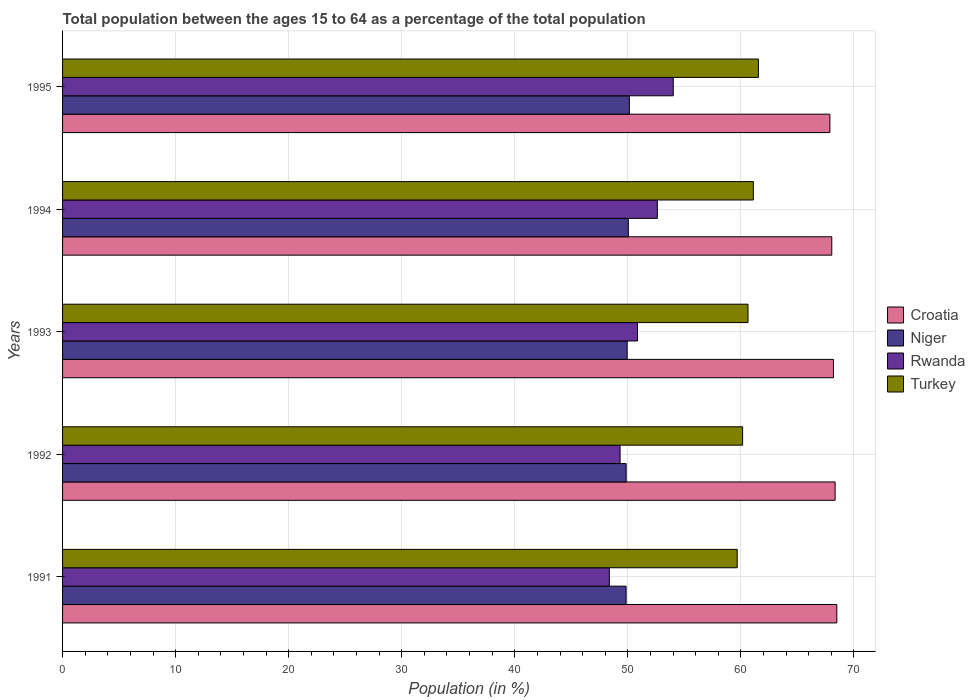How many different coloured bars are there?
Keep it short and to the point. 4. How many groups of bars are there?
Your answer should be very brief. 5. Are the number of bars on each tick of the Y-axis equal?
Provide a short and direct response. Yes. What is the label of the 3rd group of bars from the top?
Provide a succinct answer. 1993. What is the percentage of the population ages 15 to 64 in Croatia in 1994?
Give a very brief answer. 68.04. Across all years, what is the maximum percentage of the population ages 15 to 64 in Croatia?
Provide a succinct answer. 68.48. Across all years, what is the minimum percentage of the population ages 15 to 64 in Turkey?
Make the answer very short. 59.67. What is the total percentage of the population ages 15 to 64 in Turkey in the graph?
Offer a very short reply. 303.11. What is the difference between the percentage of the population ages 15 to 64 in Turkey in 1991 and that in 1993?
Provide a succinct answer. -0.96. What is the difference between the percentage of the population ages 15 to 64 in Niger in 1992 and the percentage of the population ages 15 to 64 in Turkey in 1995?
Ensure brevity in your answer.  -11.7. What is the average percentage of the population ages 15 to 64 in Rwanda per year?
Give a very brief answer. 51.03. In the year 1992, what is the difference between the percentage of the population ages 15 to 64 in Rwanda and percentage of the population ages 15 to 64 in Niger?
Make the answer very short. -0.54. What is the ratio of the percentage of the population ages 15 to 64 in Rwanda in 1992 to that in 1993?
Offer a very short reply. 0.97. Is the difference between the percentage of the population ages 15 to 64 in Rwanda in 1993 and 1994 greater than the difference between the percentage of the population ages 15 to 64 in Niger in 1993 and 1994?
Give a very brief answer. No. What is the difference between the highest and the second highest percentage of the population ages 15 to 64 in Turkey?
Provide a succinct answer. 0.45. What is the difference between the highest and the lowest percentage of the population ages 15 to 64 in Croatia?
Offer a terse response. 0.61. What does the 3rd bar from the top in 1995 represents?
Provide a short and direct response. Niger. What does the 3rd bar from the bottom in 1992 represents?
Ensure brevity in your answer.  Rwanda. Is it the case that in every year, the sum of the percentage of the population ages 15 to 64 in Niger and percentage of the population ages 15 to 64 in Turkey is greater than the percentage of the population ages 15 to 64 in Croatia?
Offer a terse response. Yes. How many bars are there?
Provide a short and direct response. 20. How many years are there in the graph?
Your answer should be compact. 5. What is the difference between two consecutive major ticks on the X-axis?
Ensure brevity in your answer.  10. Are the values on the major ticks of X-axis written in scientific E-notation?
Your answer should be compact. No. Does the graph contain any zero values?
Your answer should be compact. No. Does the graph contain grids?
Give a very brief answer. Yes. Where does the legend appear in the graph?
Your response must be concise. Center right. What is the title of the graph?
Offer a very short reply. Total population between the ages 15 to 64 as a percentage of the total population. Does "Cameroon" appear as one of the legend labels in the graph?
Your response must be concise. No. What is the label or title of the X-axis?
Your response must be concise. Population (in %). What is the label or title of the Y-axis?
Ensure brevity in your answer.  Years. What is the Population (in %) of Croatia in 1991?
Provide a succinct answer. 68.48. What is the Population (in %) in Niger in 1991?
Provide a succinct answer. 49.85. What is the Population (in %) in Rwanda in 1991?
Offer a very short reply. 48.36. What is the Population (in %) of Turkey in 1991?
Provide a short and direct response. 59.67. What is the Population (in %) of Croatia in 1992?
Your answer should be very brief. 68.33. What is the Population (in %) in Niger in 1992?
Keep it short and to the point. 49.85. What is the Population (in %) of Rwanda in 1992?
Provide a succinct answer. 49.31. What is the Population (in %) of Turkey in 1992?
Provide a short and direct response. 60.15. What is the Population (in %) in Croatia in 1993?
Offer a very short reply. 68.19. What is the Population (in %) in Niger in 1993?
Your response must be concise. 49.94. What is the Population (in %) of Rwanda in 1993?
Offer a terse response. 50.85. What is the Population (in %) in Turkey in 1993?
Offer a very short reply. 60.63. What is the Population (in %) in Croatia in 1994?
Keep it short and to the point. 68.04. What is the Population (in %) in Niger in 1994?
Ensure brevity in your answer.  50.04. What is the Population (in %) in Rwanda in 1994?
Keep it short and to the point. 52.61. What is the Population (in %) in Turkey in 1994?
Make the answer very short. 61.1. What is the Population (in %) in Croatia in 1995?
Your answer should be very brief. 67.87. What is the Population (in %) in Niger in 1995?
Offer a terse response. 50.14. What is the Population (in %) in Rwanda in 1995?
Keep it short and to the point. 54.02. What is the Population (in %) of Turkey in 1995?
Give a very brief answer. 61.55. Across all years, what is the maximum Population (in %) in Croatia?
Offer a terse response. 68.48. Across all years, what is the maximum Population (in %) of Niger?
Offer a terse response. 50.14. Across all years, what is the maximum Population (in %) in Rwanda?
Offer a very short reply. 54.02. Across all years, what is the maximum Population (in %) of Turkey?
Your answer should be compact. 61.55. Across all years, what is the minimum Population (in %) in Croatia?
Keep it short and to the point. 67.87. Across all years, what is the minimum Population (in %) in Niger?
Keep it short and to the point. 49.85. Across all years, what is the minimum Population (in %) of Rwanda?
Your answer should be compact. 48.36. Across all years, what is the minimum Population (in %) in Turkey?
Offer a very short reply. 59.67. What is the total Population (in %) of Croatia in the graph?
Your response must be concise. 340.92. What is the total Population (in %) of Niger in the graph?
Give a very brief answer. 249.82. What is the total Population (in %) in Rwanda in the graph?
Your answer should be compact. 255.16. What is the total Population (in %) of Turkey in the graph?
Provide a succinct answer. 303.11. What is the difference between the Population (in %) in Croatia in 1991 and that in 1992?
Ensure brevity in your answer.  0.15. What is the difference between the Population (in %) of Niger in 1991 and that in 1992?
Your answer should be compact. -0. What is the difference between the Population (in %) in Rwanda in 1991 and that in 1992?
Provide a short and direct response. -0.95. What is the difference between the Population (in %) in Turkey in 1991 and that in 1992?
Your response must be concise. -0.48. What is the difference between the Population (in %) in Croatia in 1991 and that in 1993?
Your response must be concise. 0.3. What is the difference between the Population (in %) of Niger in 1991 and that in 1993?
Keep it short and to the point. -0.09. What is the difference between the Population (in %) in Rwanda in 1991 and that in 1993?
Your answer should be very brief. -2.49. What is the difference between the Population (in %) of Turkey in 1991 and that in 1993?
Ensure brevity in your answer.  -0.96. What is the difference between the Population (in %) of Croatia in 1991 and that in 1994?
Provide a short and direct response. 0.44. What is the difference between the Population (in %) in Niger in 1991 and that in 1994?
Provide a succinct answer. -0.2. What is the difference between the Population (in %) in Rwanda in 1991 and that in 1994?
Ensure brevity in your answer.  -4.25. What is the difference between the Population (in %) in Turkey in 1991 and that in 1994?
Ensure brevity in your answer.  -1.43. What is the difference between the Population (in %) of Croatia in 1991 and that in 1995?
Your answer should be compact. 0.61. What is the difference between the Population (in %) in Niger in 1991 and that in 1995?
Your answer should be very brief. -0.29. What is the difference between the Population (in %) of Rwanda in 1991 and that in 1995?
Ensure brevity in your answer.  -5.65. What is the difference between the Population (in %) in Turkey in 1991 and that in 1995?
Your response must be concise. -1.88. What is the difference between the Population (in %) in Croatia in 1992 and that in 1993?
Give a very brief answer. 0.15. What is the difference between the Population (in %) in Niger in 1992 and that in 1993?
Provide a succinct answer. -0.09. What is the difference between the Population (in %) of Rwanda in 1992 and that in 1993?
Your answer should be compact. -1.54. What is the difference between the Population (in %) in Turkey in 1992 and that in 1993?
Provide a succinct answer. -0.48. What is the difference between the Population (in %) in Croatia in 1992 and that in 1994?
Provide a short and direct response. 0.29. What is the difference between the Population (in %) in Niger in 1992 and that in 1994?
Offer a terse response. -0.19. What is the difference between the Population (in %) in Rwanda in 1992 and that in 1994?
Make the answer very short. -3.3. What is the difference between the Population (in %) of Turkey in 1992 and that in 1994?
Your answer should be compact. -0.95. What is the difference between the Population (in %) of Croatia in 1992 and that in 1995?
Your response must be concise. 0.46. What is the difference between the Population (in %) in Niger in 1992 and that in 1995?
Provide a short and direct response. -0.28. What is the difference between the Population (in %) of Rwanda in 1992 and that in 1995?
Offer a very short reply. -4.7. What is the difference between the Population (in %) in Turkey in 1992 and that in 1995?
Offer a terse response. -1.4. What is the difference between the Population (in %) of Croatia in 1993 and that in 1994?
Make the answer very short. 0.15. What is the difference between the Population (in %) in Niger in 1993 and that in 1994?
Provide a succinct answer. -0.1. What is the difference between the Population (in %) in Rwanda in 1993 and that in 1994?
Provide a short and direct response. -1.76. What is the difference between the Population (in %) in Turkey in 1993 and that in 1994?
Your answer should be compact. -0.47. What is the difference between the Population (in %) of Croatia in 1993 and that in 1995?
Offer a terse response. 0.32. What is the difference between the Population (in %) of Niger in 1993 and that in 1995?
Your answer should be compact. -0.2. What is the difference between the Population (in %) of Rwanda in 1993 and that in 1995?
Provide a succinct answer. -3.16. What is the difference between the Population (in %) in Turkey in 1993 and that in 1995?
Your answer should be compact. -0.92. What is the difference between the Population (in %) in Croatia in 1994 and that in 1995?
Ensure brevity in your answer.  0.17. What is the difference between the Population (in %) of Niger in 1994 and that in 1995?
Your answer should be very brief. -0.09. What is the difference between the Population (in %) of Rwanda in 1994 and that in 1995?
Give a very brief answer. -1.41. What is the difference between the Population (in %) in Turkey in 1994 and that in 1995?
Your response must be concise. -0.45. What is the difference between the Population (in %) of Croatia in 1991 and the Population (in %) of Niger in 1992?
Offer a very short reply. 18.63. What is the difference between the Population (in %) in Croatia in 1991 and the Population (in %) in Rwanda in 1992?
Your response must be concise. 19.17. What is the difference between the Population (in %) in Croatia in 1991 and the Population (in %) in Turkey in 1992?
Keep it short and to the point. 8.33. What is the difference between the Population (in %) in Niger in 1991 and the Population (in %) in Rwanda in 1992?
Offer a very short reply. 0.53. What is the difference between the Population (in %) in Niger in 1991 and the Population (in %) in Turkey in 1992?
Your answer should be very brief. -10.3. What is the difference between the Population (in %) in Rwanda in 1991 and the Population (in %) in Turkey in 1992?
Provide a succinct answer. -11.79. What is the difference between the Population (in %) in Croatia in 1991 and the Population (in %) in Niger in 1993?
Ensure brevity in your answer.  18.54. What is the difference between the Population (in %) in Croatia in 1991 and the Population (in %) in Rwanda in 1993?
Keep it short and to the point. 17.63. What is the difference between the Population (in %) in Croatia in 1991 and the Population (in %) in Turkey in 1993?
Offer a very short reply. 7.85. What is the difference between the Population (in %) in Niger in 1991 and the Population (in %) in Rwanda in 1993?
Offer a terse response. -1.01. What is the difference between the Population (in %) of Niger in 1991 and the Population (in %) of Turkey in 1993?
Your answer should be very brief. -10.78. What is the difference between the Population (in %) of Rwanda in 1991 and the Population (in %) of Turkey in 1993?
Provide a succinct answer. -12.27. What is the difference between the Population (in %) of Croatia in 1991 and the Population (in %) of Niger in 1994?
Provide a succinct answer. 18.44. What is the difference between the Population (in %) of Croatia in 1991 and the Population (in %) of Rwanda in 1994?
Give a very brief answer. 15.87. What is the difference between the Population (in %) in Croatia in 1991 and the Population (in %) in Turkey in 1994?
Your answer should be very brief. 7.38. What is the difference between the Population (in %) of Niger in 1991 and the Population (in %) of Rwanda in 1994?
Provide a succinct answer. -2.77. What is the difference between the Population (in %) of Niger in 1991 and the Population (in %) of Turkey in 1994?
Make the answer very short. -11.25. What is the difference between the Population (in %) of Rwanda in 1991 and the Population (in %) of Turkey in 1994?
Provide a succinct answer. -12.74. What is the difference between the Population (in %) of Croatia in 1991 and the Population (in %) of Niger in 1995?
Provide a succinct answer. 18.35. What is the difference between the Population (in %) of Croatia in 1991 and the Population (in %) of Rwanda in 1995?
Keep it short and to the point. 14.47. What is the difference between the Population (in %) in Croatia in 1991 and the Population (in %) in Turkey in 1995?
Your answer should be very brief. 6.93. What is the difference between the Population (in %) of Niger in 1991 and the Population (in %) of Rwanda in 1995?
Give a very brief answer. -4.17. What is the difference between the Population (in %) of Niger in 1991 and the Population (in %) of Turkey in 1995?
Offer a very short reply. -11.7. What is the difference between the Population (in %) of Rwanda in 1991 and the Population (in %) of Turkey in 1995?
Provide a short and direct response. -13.19. What is the difference between the Population (in %) of Croatia in 1992 and the Population (in %) of Niger in 1993?
Your answer should be compact. 18.39. What is the difference between the Population (in %) in Croatia in 1992 and the Population (in %) in Rwanda in 1993?
Make the answer very short. 17.48. What is the difference between the Population (in %) of Croatia in 1992 and the Population (in %) of Turkey in 1993?
Your answer should be very brief. 7.7. What is the difference between the Population (in %) in Niger in 1992 and the Population (in %) in Rwanda in 1993?
Offer a very short reply. -1. What is the difference between the Population (in %) of Niger in 1992 and the Population (in %) of Turkey in 1993?
Your answer should be very brief. -10.78. What is the difference between the Population (in %) in Rwanda in 1992 and the Population (in %) in Turkey in 1993?
Your response must be concise. -11.32. What is the difference between the Population (in %) of Croatia in 1992 and the Population (in %) of Niger in 1994?
Provide a succinct answer. 18.29. What is the difference between the Population (in %) of Croatia in 1992 and the Population (in %) of Rwanda in 1994?
Your answer should be compact. 15.72. What is the difference between the Population (in %) of Croatia in 1992 and the Population (in %) of Turkey in 1994?
Keep it short and to the point. 7.23. What is the difference between the Population (in %) in Niger in 1992 and the Population (in %) in Rwanda in 1994?
Offer a terse response. -2.76. What is the difference between the Population (in %) of Niger in 1992 and the Population (in %) of Turkey in 1994?
Provide a short and direct response. -11.25. What is the difference between the Population (in %) of Rwanda in 1992 and the Population (in %) of Turkey in 1994?
Your answer should be very brief. -11.79. What is the difference between the Population (in %) of Croatia in 1992 and the Population (in %) of Niger in 1995?
Keep it short and to the point. 18.2. What is the difference between the Population (in %) in Croatia in 1992 and the Population (in %) in Rwanda in 1995?
Make the answer very short. 14.32. What is the difference between the Population (in %) of Croatia in 1992 and the Population (in %) of Turkey in 1995?
Your answer should be compact. 6.78. What is the difference between the Population (in %) of Niger in 1992 and the Population (in %) of Rwanda in 1995?
Give a very brief answer. -4.17. What is the difference between the Population (in %) in Niger in 1992 and the Population (in %) in Turkey in 1995?
Make the answer very short. -11.7. What is the difference between the Population (in %) in Rwanda in 1992 and the Population (in %) in Turkey in 1995?
Ensure brevity in your answer.  -12.24. What is the difference between the Population (in %) of Croatia in 1993 and the Population (in %) of Niger in 1994?
Keep it short and to the point. 18.14. What is the difference between the Population (in %) of Croatia in 1993 and the Population (in %) of Rwanda in 1994?
Your response must be concise. 15.58. What is the difference between the Population (in %) of Croatia in 1993 and the Population (in %) of Turkey in 1994?
Make the answer very short. 7.09. What is the difference between the Population (in %) in Niger in 1993 and the Population (in %) in Rwanda in 1994?
Ensure brevity in your answer.  -2.67. What is the difference between the Population (in %) of Niger in 1993 and the Population (in %) of Turkey in 1994?
Offer a terse response. -11.16. What is the difference between the Population (in %) in Rwanda in 1993 and the Population (in %) in Turkey in 1994?
Offer a very short reply. -10.25. What is the difference between the Population (in %) in Croatia in 1993 and the Population (in %) in Niger in 1995?
Your answer should be very brief. 18.05. What is the difference between the Population (in %) in Croatia in 1993 and the Population (in %) in Rwanda in 1995?
Make the answer very short. 14.17. What is the difference between the Population (in %) in Croatia in 1993 and the Population (in %) in Turkey in 1995?
Keep it short and to the point. 6.64. What is the difference between the Population (in %) in Niger in 1993 and the Population (in %) in Rwanda in 1995?
Provide a short and direct response. -4.08. What is the difference between the Population (in %) of Niger in 1993 and the Population (in %) of Turkey in 1995?
Make the answer very short. -11.61. What is the difference between the Population (in %) in Rwanda in 1993 and the Population (in %) in Turkey in 1995?
Offer a terse response. -10.7. What is the difference between the Population (in %) in Croatia in 1994 and the Population (in %) in Niger in 1995?
Offer a very short reply. 17.9. What is the difference between the Population (in %) of Croatia in 1994 and the Population (in %) of Rwanda in 1995?
Provide a short and direct response. 14.02. What is the difference between the Population (in %) in Croatia in 1994 and the Population (in %) in Turkey in 1995?
Your response must be concise. 6.49. What is the difference between the Population (in %) in Niger in 1994 and the Population (in %) in Rwanda in 1995?
Keep it short and to the point. -3.97. What is the difference between the Population (in %) of Niger in 1994 and the Population (in %) of Turkey in 1995?
Give a very brief answer. -11.51. What is the difference between the Population (in %) in Rwanda in 1994 and the Population (in %) in Turkey in 1995?
Give a very brief answer. -8.94. What is the average Population (in %) in Croatia per year?
Your answer should be compact. 68.18. What is the average Population (in %) in Niger per year?
Your answer should be very brief. 49.96. What is the average Population (in %) in Rwanda per year?
Ensure brevity in your answer.  51.03. What is the average Population (in %) in Turkey per year?
Offer a terse response. 60.62. In the year 1991, what is the difference between the Population (in %) of Croatia and Population (in %) of Niger?
Offer a terse response. 18.64. In the year 1991, what is the difference between the Population (in %) in Croatia and Population (in %) in Rwanda?
Offer a terse response. 20.12. In the year 1991, what is the difference between the Population (in %) in Croatia and Population (in %) in Turkey?
Offer a very short reply. 8.81. In the year 1991, what is the difference between the Population (in %) of Niger and Population (in %) of Rwanda?
Offer a very short reply. 1.48. In the year 1991, what is the difference between the Population (in %) of Niger and Population (in %) of Turkey?
Keep it short and to the point. -9.83. In the year 1991, what is the difference between the Population (in %) of Rwanda and Population (in %) of Turkey?
Your answer should be compact. -11.31. In the year 1992, what is the difference between the Population (in %) in Croatia and Population (in %) in Niger?
Give a very brief answer. 18.48. In the year 1992, what is the difference between the Population (in %) in Croatia and Population (in %) in Rwanda?
Ensure brevity in your answer.  19.02. In the year 1992, what is the difference between the Population (in %) in Croatia and Population (in %) in Turkey?
Offer a terse response. 8.18. In the year 1992, what is the difference between the Population (in %) of Niger and Population (in %) of Rwanda?
Give a very brief answer. 0.54. In the year 1992, what is the difference between the Population (in %) in Niger and Population (in %) in Turkey?
Make the answer very short. -10.3. In the year 1992, what is the difference between the Population (in %) of Rwanda and Population (in %) of Turkey?
Your answer should be very brief. -10.84. In the year 1993, what is the difference between the Population (in %) in Croatia and Population (in %) in Niger?
Your answer should be very brief. 18.25. In the year 1993, what is the difference between the Population (in %) in Croatia and Population (in %) in Rwanda?
Provide a short and direct response. 17.33. In the year 1993, what is the difference between the Population (in %) of Croatia and Population (in %) of Turkey?
Give a very brief answer. 7.56. In the year 1993, what is the difference between the Population (in %) in Niger and Population (in %) in Rwanda?
Ensure brevity in your answer.  -0.91. In the year 1993, what is the difference between the Population (in %) of Niger and Population (in %) of Turkey?
Provide a short and direct response. -10.69. In the year 1993, what is the difference between the Population (in %) in Rwanda and Population (in %) in Turkey?
Your answer should be very brief. -9.78. In the year 1994, what is the difference between the Population (in %) of Croatia and Population (in %) of Niger?
Ensure brevity in your answer.  18. In the year 1994, what is the difference between the Population (in %) in Croatia and Population (in %) in Rwanda?
Make the answer very short. 15.43. In the year 1994, what is the difference between the Population (in %) of Croatia and Population (in %) of Turkey?
Make the answer very short. 6.94. In the year 1994, what is the difference between the Population (in %) in Niger and Population (in %) in Rwanda?
Your response must be concise. -2.57. In the year 1994, what is the difference between the Population (in %) in Niger and Population (in %) in Turkey?
Offer a very short reply. -11.06. In the year 1994, what is the difference between the Population (in %) of Rwanda and Population (in %) of Turkey?
Ensure brevity in your answer.  -8.49. In the year 1995, what is the difference between the Population (in %) in Croatia and Population (in %) in Niger?
Make the answer very short. 17.74. In the year 1995, what is the difference between the Population (in %) in Croatia and Population (in %) in Rwanda?
Your answer should be very brief. 13.85. In the year 1995, what is the difference between the Population (in %) of Croatia and Population (in %) of Turkey?
Your response must be concise. 6.32. In the year 1995, what is the difference between the Population (in %) of Niger and Population (in %) of Rwanda?
Make the answer very short. -3.88. In the year 1995, what is the difference between the Population (in %) of Niger and Population (in %) of Turkey?
Provide a short and direct response. -11.41. In the year 1995, what is the difference between the Population (in %) of Rwanda and Population (in %) of Turkey?
Keep it short and to the point. -7.53. What is the ratio of the Population (in %) in Croatia in 1991 to that in 1992?
Keep it short and to the point. 1. What is the ratio of the Population (in %) of Niger in 1991 to that in 1992?
Ensure brevity in your answer.  1. What is the ratio of the Population (in %) of Rwanda in 1991 to that in 1992?
Provide a short and direct response. 0.98. What is the ratio of the Population (in %) in Turkey in 1991 to that in 1992?
Provide a succinct answer. 0.99. What is the ratio of the Population (in %) of Croatia in 1991 to that in 1993?
Your answer should be compact. 1. What is the ratio of the Population (in %) of Niger in 1991 to that in 1993?
Make the answer very short. 1. What is the ratio of the Population (in %) of Rwanda in 1991 to that in 1993?
Offer a very short reply. 0.95. What is the ratio of the Population (in %) of Turkey in 1991 to that in 1993?
Your answer should be very brief. 0.98. What is the ratio of the Population (in %) of Rwanda in 1991 to that in 1994?
Provide a succinct answer. 0.92. What is the ratio of the Population (in %) of Turkey in 1991 to that in 1994?
Give a very brief answer. 0.98. What is the ratio of the Population (in %) of Croatia in 1991 to that in 1995?
Ensure brevity in your answer.  1.01. What is the ratio of the Population (in %) of Rwanda in 1991 to that in 1995?
Ensure brevity in your answer.  0.9. What is the ratio of the Population (in %) of Turkey in 1991 to that in 1995?
Provide a short and direct response. 0.97. What is the ratio of the Population (in %) of Niger in 1992 to that in 1993?
Offer a terse response. 1. What is the ratio of the Population (in %) of Rwanda in 1992 to that in 1993?
Provide a succinct answer. 0.97. What is the ratio of the Population (in %) of Croatia in 1992 to that in 1994?
Provide a succinct answer. 1. What is the ratio of the Population (in %) in Rwanda in 1992 to that in 1994?
Provide a short and direct response. 0.94. What is the ratio of the Population (in %) of Turkey in 1992 to that in 1994?
Make the answer very short. 0.98. What is the ratio of the Population (in %) in Croatia in 1992 to that in 1995?
Make the answer very short. 1.01. What is the ratio of the Population (in %) in Rwanda in 1992 to that in 1995?
Your answer should be very brief. 0.91. What is the ratio of the Population (in %) of Turkey in 1992 to that in 1995?
Provide a short and direct response. 0.98. What is the ratio of the Population (in %) in Rwanda in 1993 to that in 1994?
Provide a succinct answer. 0.97. What is the ratio of the Population (in %) of Croatia in 1993 to that in 1995?
Your answer should be very brief. 1. What is the ratio of the Population (in %) in Rwanda in 1993 to that in 1995?
Ensure brevity in your answer.  0.94. What is the ratio of the Population (in %) of Turkey in 1993 to that in 1995?
Make the answer very short. 0.99. What is the ratio of the Population (in %) of Croatia in 1994 to that in 1995?
Make the answer very short. 1. What is the ratio of the Population (in %) in Rwanda in 1994 to that in 1995?
Ensure brevity in your answer.  0.97. What is the ratio of the Population (in %) of Turkey in 1994 to that in 1995?
Give a very brief answer. 0.99. What is the difference between the highest and the second highest Population (in %) of Croatia?
Ensure brevity in your answer.  0.15. What is the difference between the highest and the second highest Population (in %) in Niger?
Make the answer very short. 0.09. What is the difference between the highest and the second highest Population (in %) of Rwanda?
Give a very brief answer. 1.41. What is the difference between the highest and the second highest Population (in %) in Turkey?
Provide a short and direct response. 0.45. What is the difference between the highest and the lowest Population (in %) in Croatia?
Give a very brief answer. 0.61. What is the difference between the highest and the lowest Population (in %) of Niger?
Your answer should be very brief. 0.29. What is the difference between the highest and the lowest Population (in %) of Rwanda?
Provide a short and direct response. 5.65. What is the difference between the highest and the lowest Population (in %) of Turkey?
Ensure brevity in your answer.  1.88. 